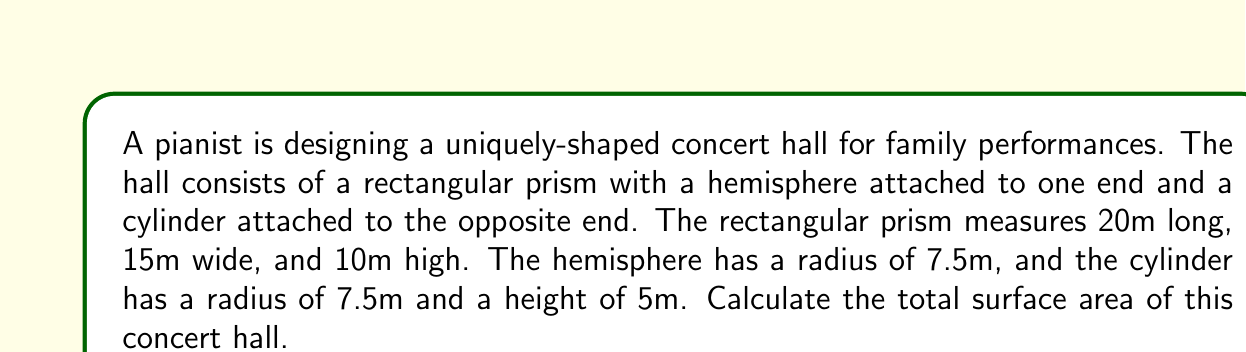Can you solve this math problem? Let's break this down step-by-step:

1. Calculate the surface area of the rectangular prism:
   - Front and back: $2 * (15m * 10m) = 300m^2$
   - Top and bottom: $2 * (20m * 15m) = 600m^2$
   - Left side: $1 * (20m * 10m) = 200m^2$
   - Total for prism: $300 + 600 + 200 = 1100m^2$

2. Calculate the surface area of the hemisphere:
   - Surface area of a hemisphere: $2\pi r^2$
   - $SA_{hemisphere} = 2\pi (7.5m)^2 = 353.43m^2$

3. Calculate the surface area of the cylinder:
   - Lateral surface area: $2\pi rh = 2\pi * 7.5m * 5m = 235.62m^2$
   - One circular base: $\pi r^2 = \pi * (7.5m)^2 = 176.71m^2$
   - Total for cylinder: $235.62m^2 + 176.71m^2 = 412.33m^2$

4. Sum up the total surface area:
   - $SA_{total} = 1100m^2 + 353.43m^2 + 412.33m^2 = 1865.76m^2$

Therefore, the total surface area of the concert hall is approximately 1865.76 square meters.
Answer: $1865.76m^2$ 